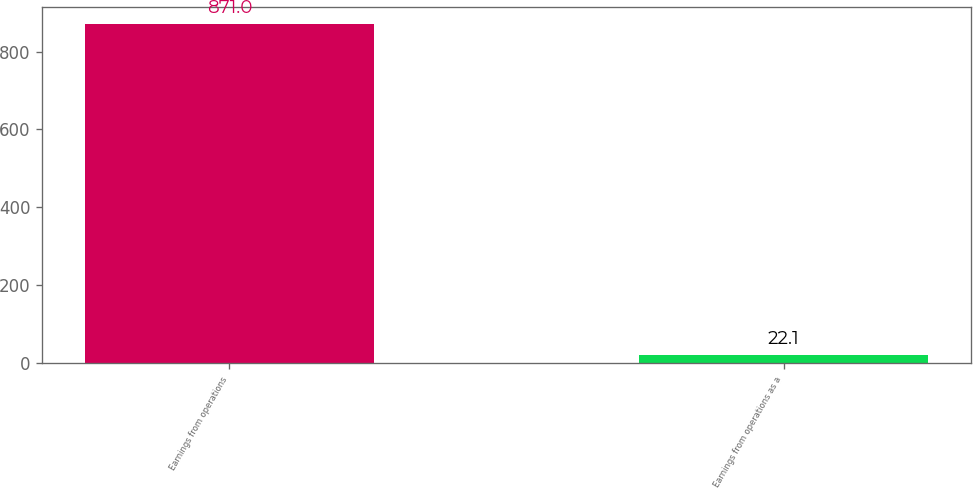<chart> <loc_0><loc_0><loc_500><loc_500><bar_chart><fcel>Earnings from operations<fcel>Earnings from operations as a<nl><fcel>871<fcel>22.1<nl></chart> 